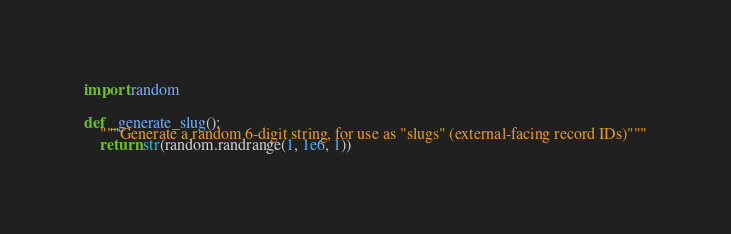Convert code to text. <code><loc_0><loc_0><loc_500><loc_500><_Python_>import random


def _generate_slug():
    """Generate a random 6-digit string, for use as "slugs" (external-facing record IDs)"""
    return str(random.randrange(1, 1e6, 1))
</code> 